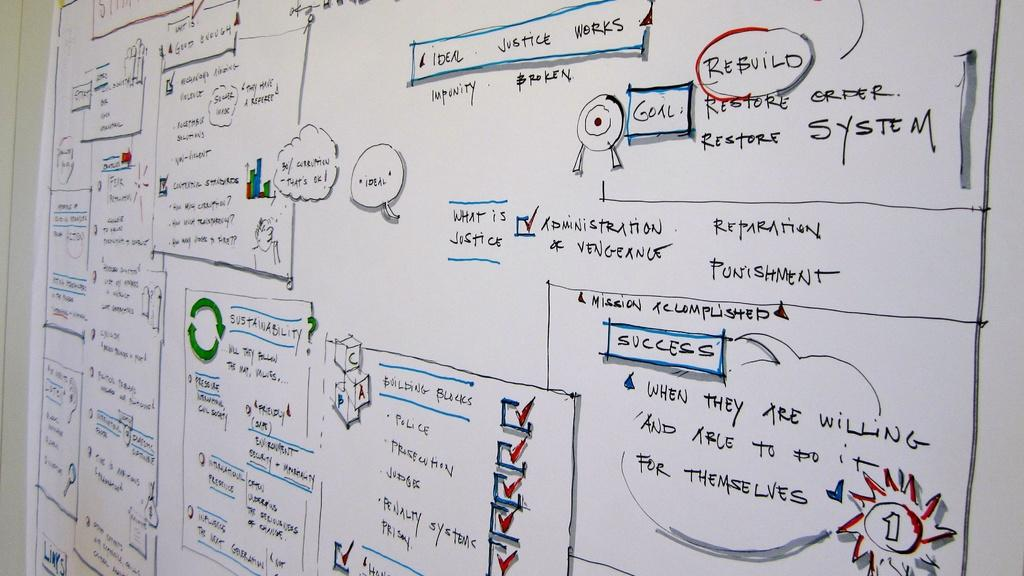What is the primary color of the sheet in the image? The sheet in the image is white in color. What is written on the sheet? The sheet has black color text on it. How many stitches are visible on the sheet in the image? There are no stitches visible on the sheet in the image. What month is depicted on the sheet in the image? There is no month depicted on the sheet in the image. 